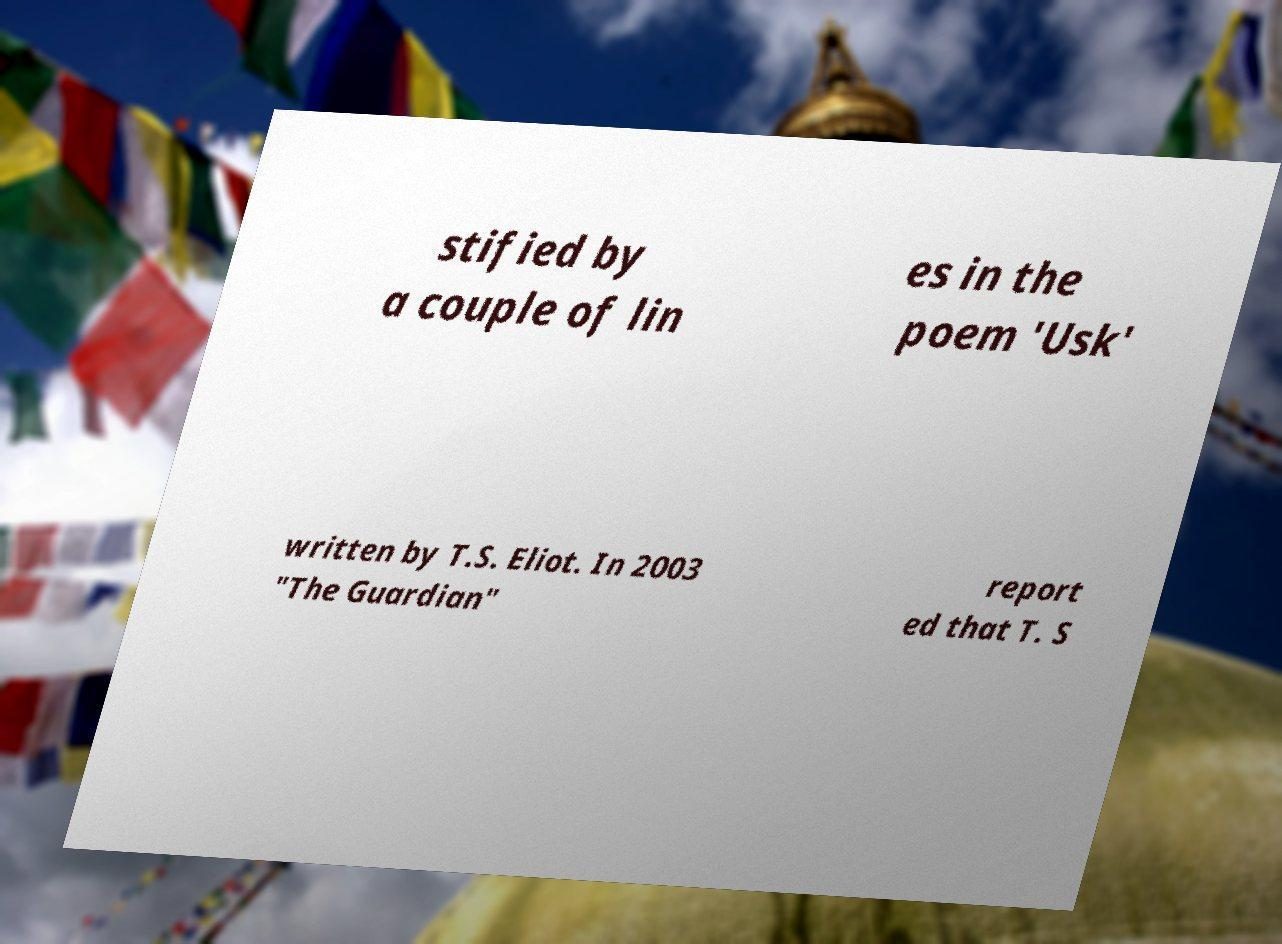For documentation purposes, I need the text within this image transcribed. Could you provide that? stified by a couple of lin es in the poem 'Usk' written by T.S. Eliot. In 2003 "The Guardian" report ed that T. S 